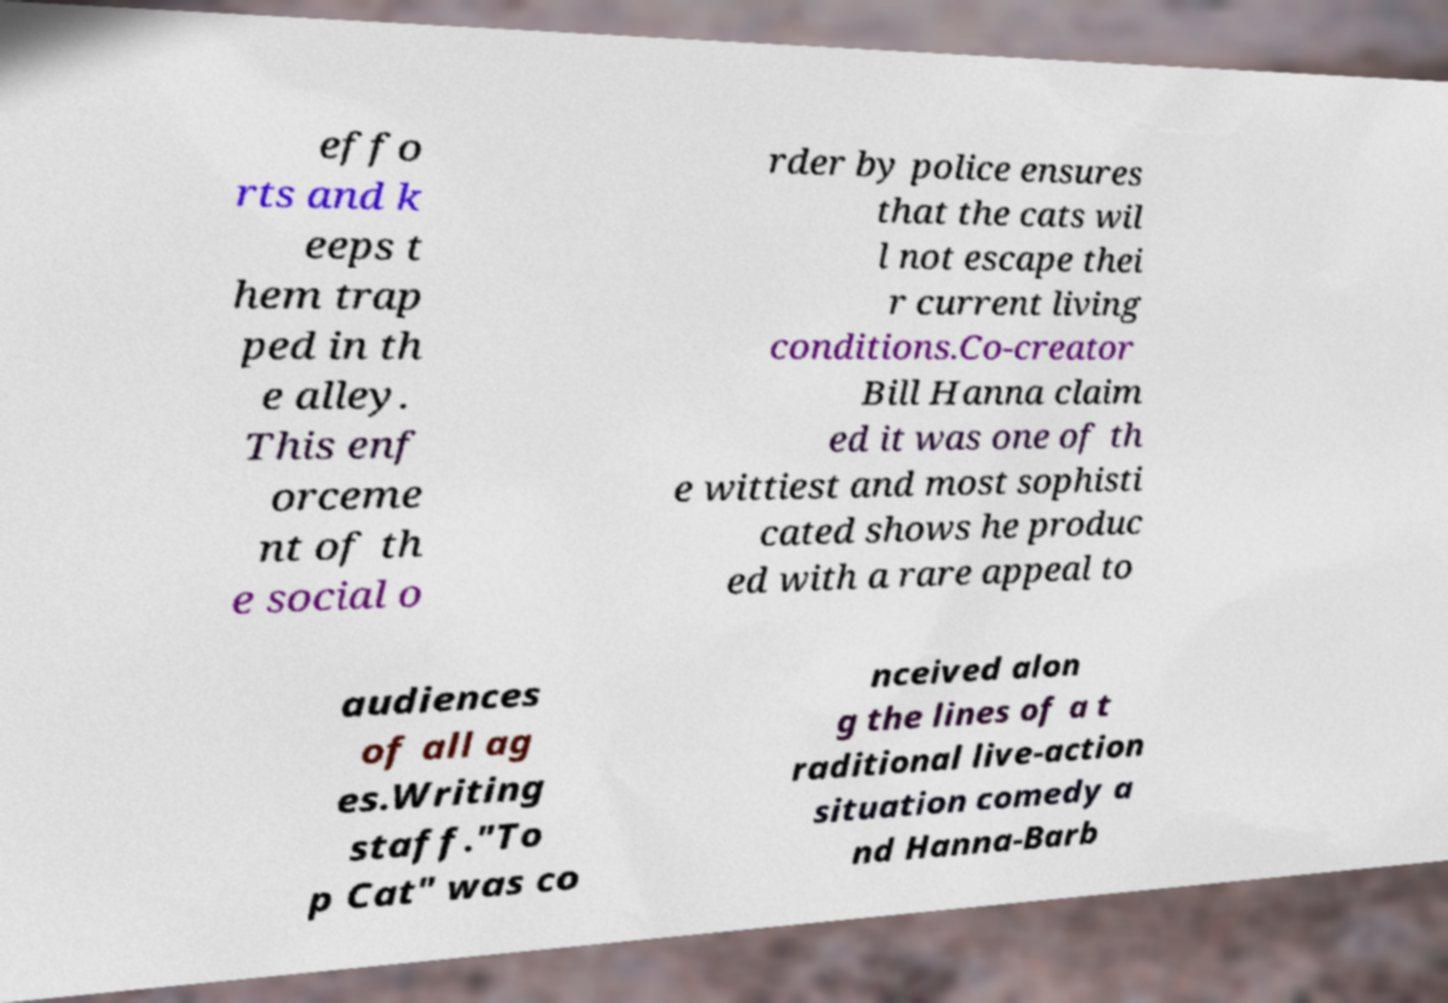Can you accurately transcribe the text from the provided image for me? effo rts and k eeps t hem trap ped in th e alley. This enf orceme nt of th e social o rder by police ensures that the cats wil l not escape thei r current living conditions.Co-creator Bill Hanna claim ed it was one of th e wittiest and most sophisti cated shows he produc ed with a rare appeal to audiences of all ag es.Writing staff."To p Cat" was co nceived alon g the lines of a t raditional live-action situation comedy a nd Hanna-Barb 